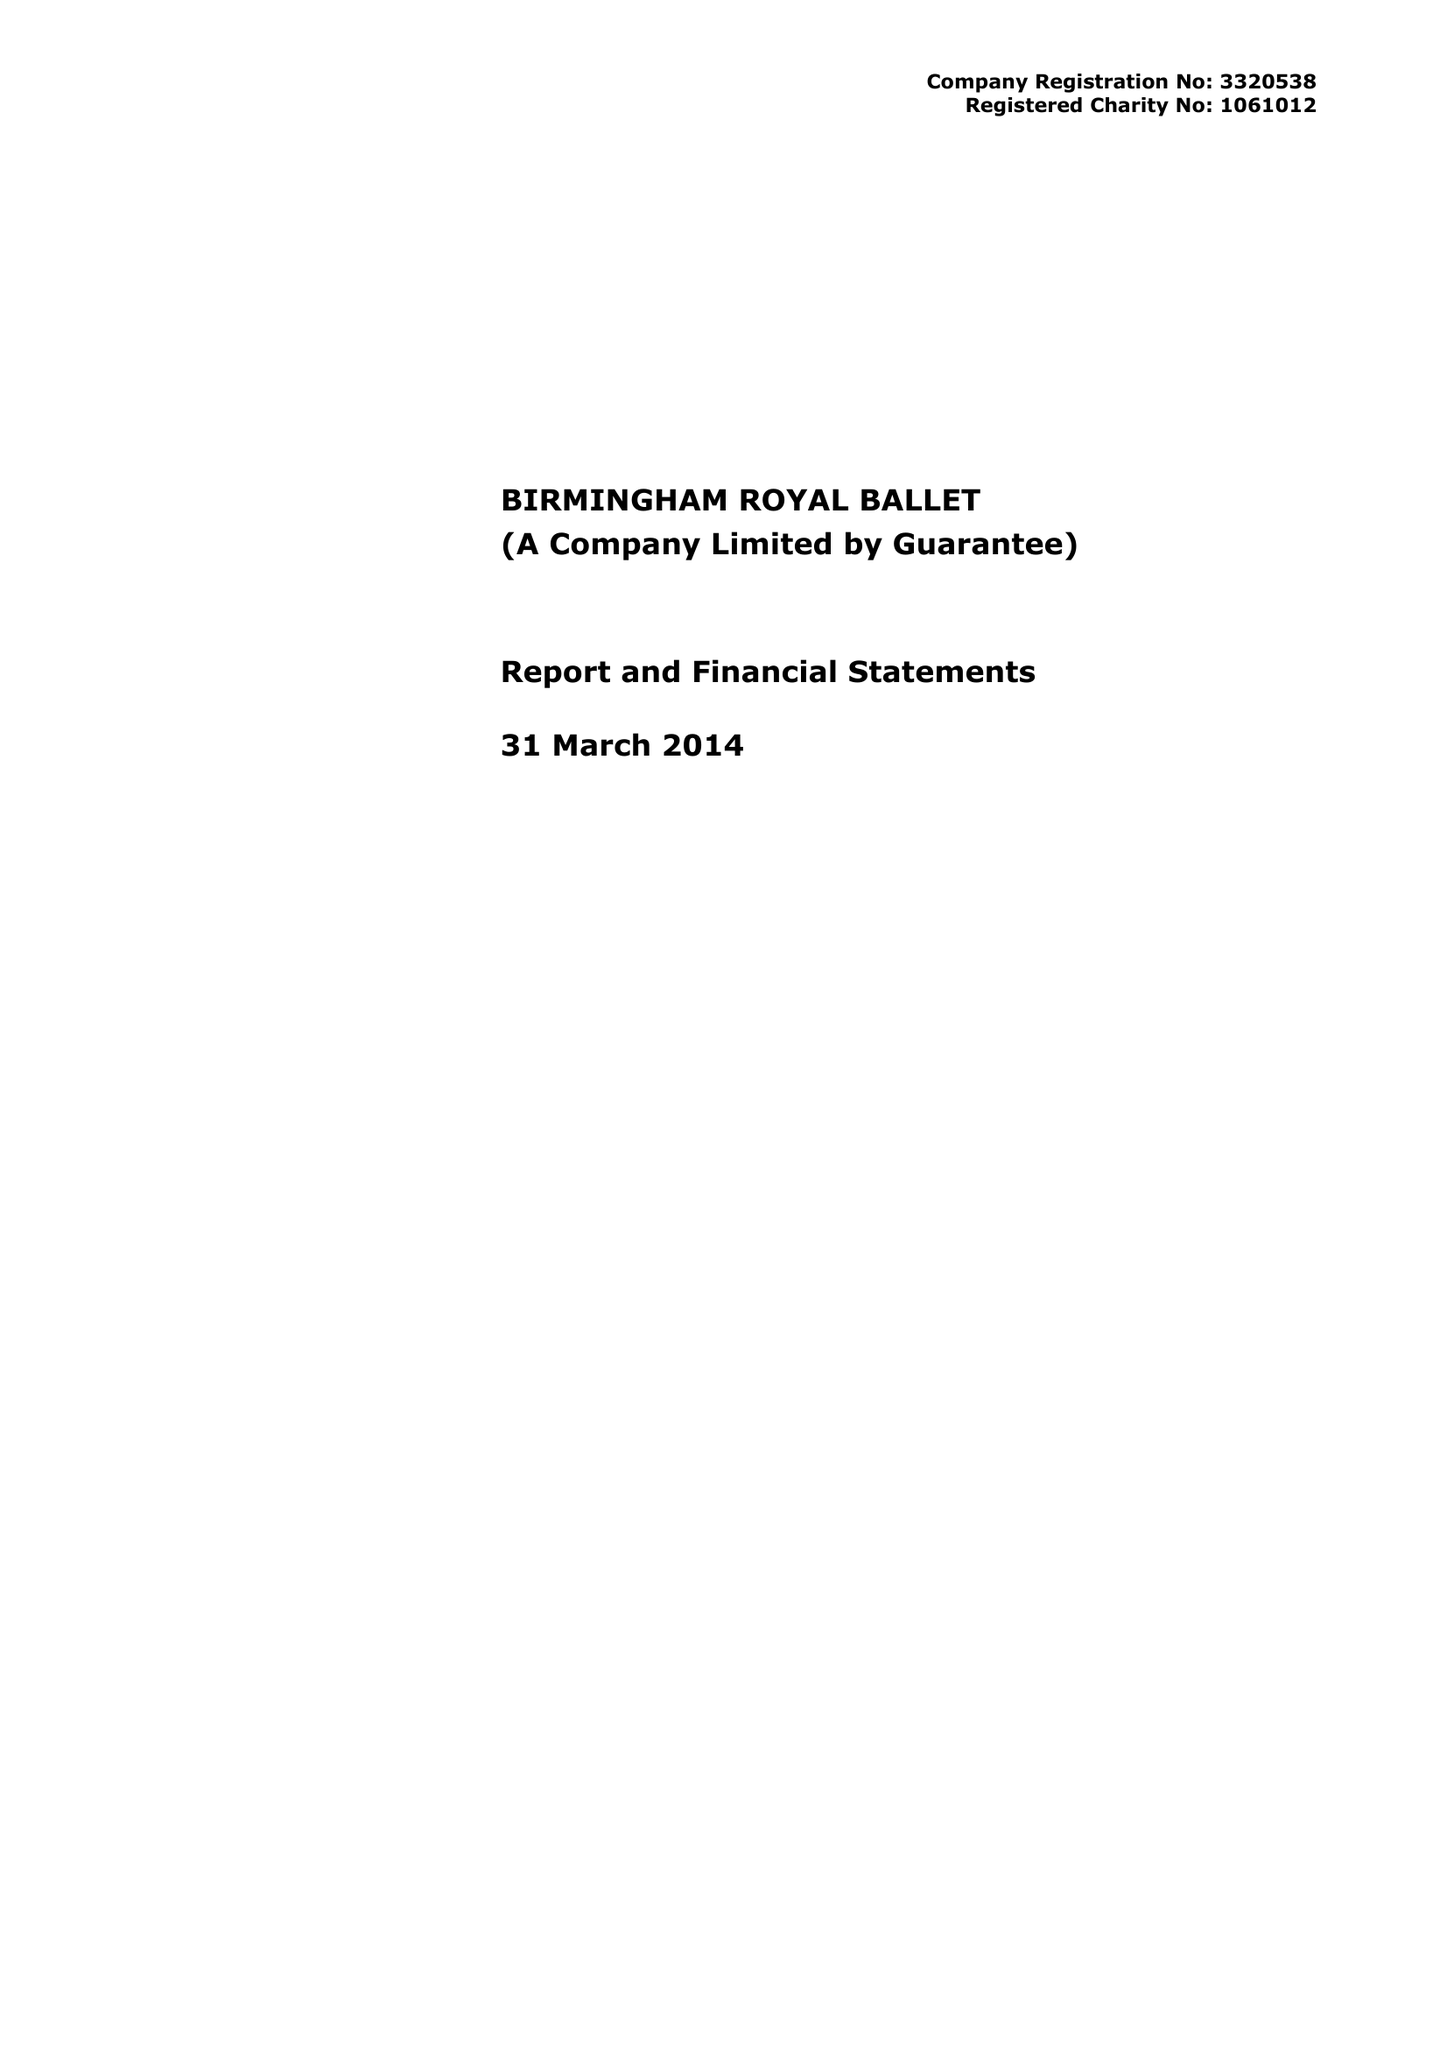What is the value for the address__street_line?
Answer the question using a single word or phrase. THORP STREET 